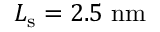<formula> <loc_0><loc_0><loc_500><loc_500>L _ { s } = 2 . 5 n m</formula> 